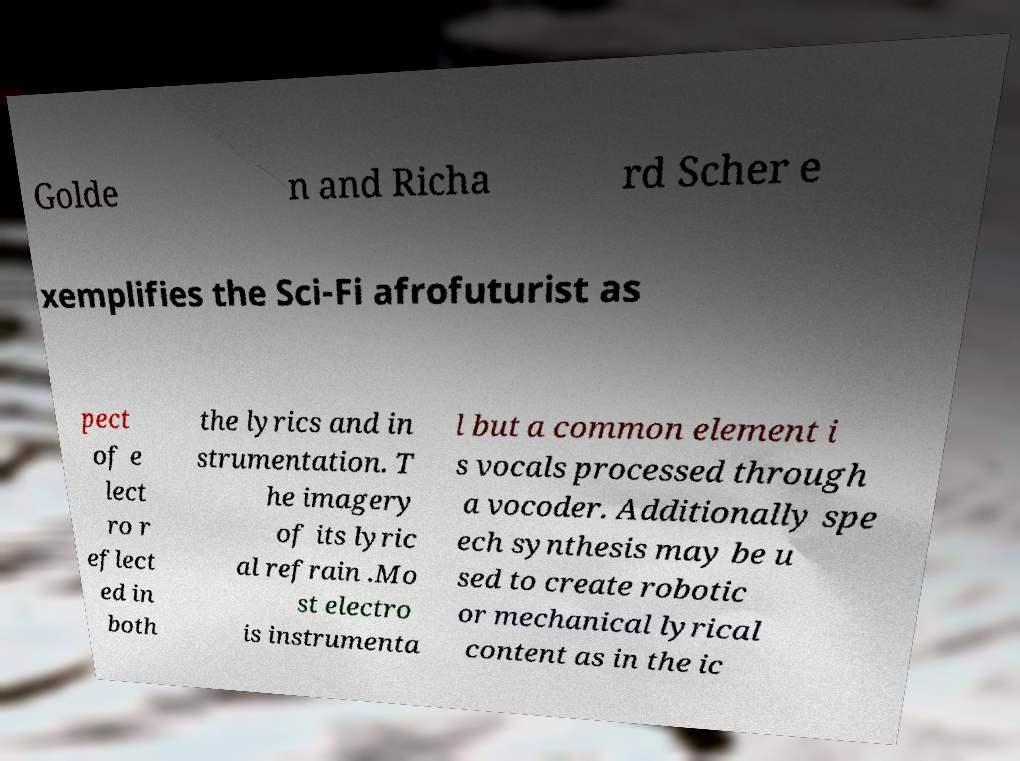I need the written content from this picture converted into text. Can you do that? Golde n and Richa rd Scher e xemplifies the Sci-Fi afrofuturist as pect of e lect ro r eflect ed in both the lyrics and in strumentation. T he imagery of its lyric al refrain .Mo st electro is instrumenta l but a common element i s vocals processed through a vocoder. Additionally spe ech synthesis may be u sed to create robotic or mechanical lyrical content as in the ic 